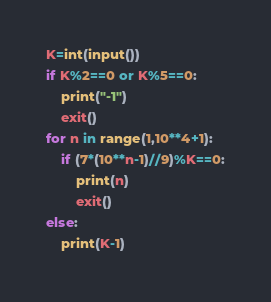<code> <loc_0><loc_0><loc_500><loc_500><_Python_>K=int(input())
if K%2==0 or K%5==0:
	print("-1")
	exit()
for n in range(1,10**4+1):
	if (7*(10**n-1)//9)%K==0:
		print(n)
		exit()
else:
	print(K-1)</code> 